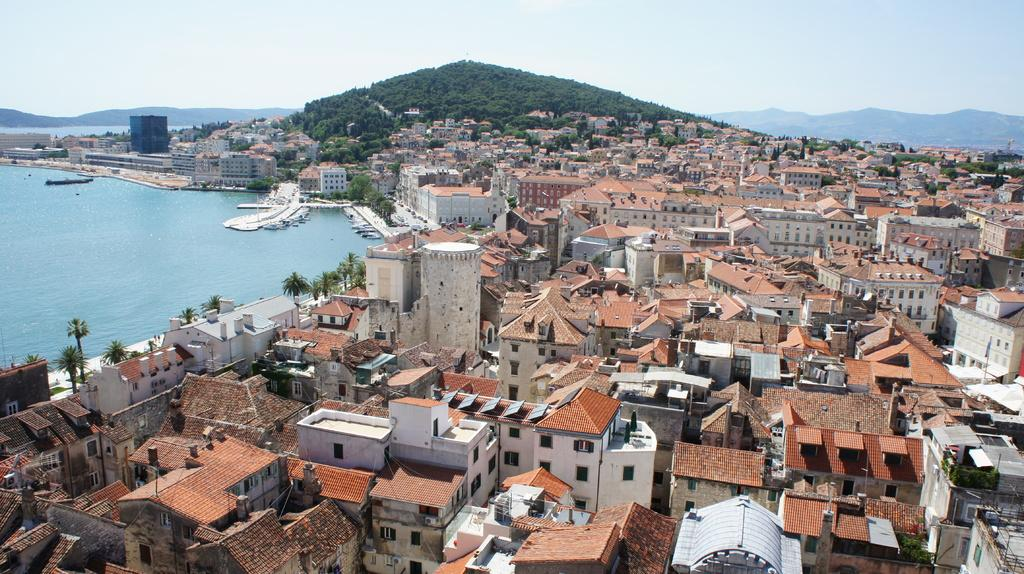What type of structures can be seen in the image? There are buildings in the image. What other natural elements are present in the image? There are trees in the image. What can be seen floating on the water in the image? There are boats in the water. What type of landscape feature is visible in the background of the image? There are hills visible in the background of the image. Where is the plant located in the image? There is no specific plant mentioned in the provided facts, so it cannot be determined where a plant might be located in the image. Can you tell me how many people are sleeping in the image? There is no indication of people or sleeping in the image, so it cannot be determined how many people might be sleeping. 